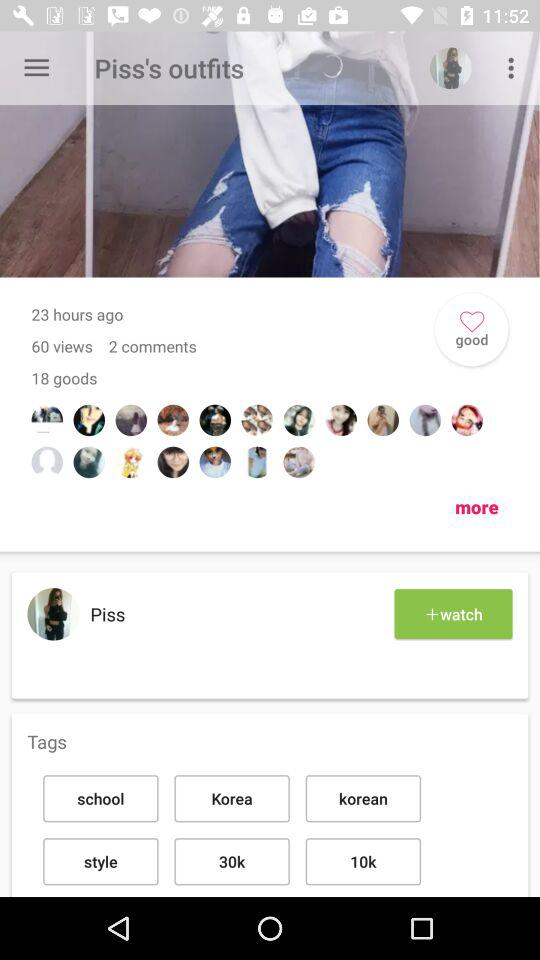When did "Piss" become a member?
When the provided information is insufficient, respond with <no answer>. <no answer> 